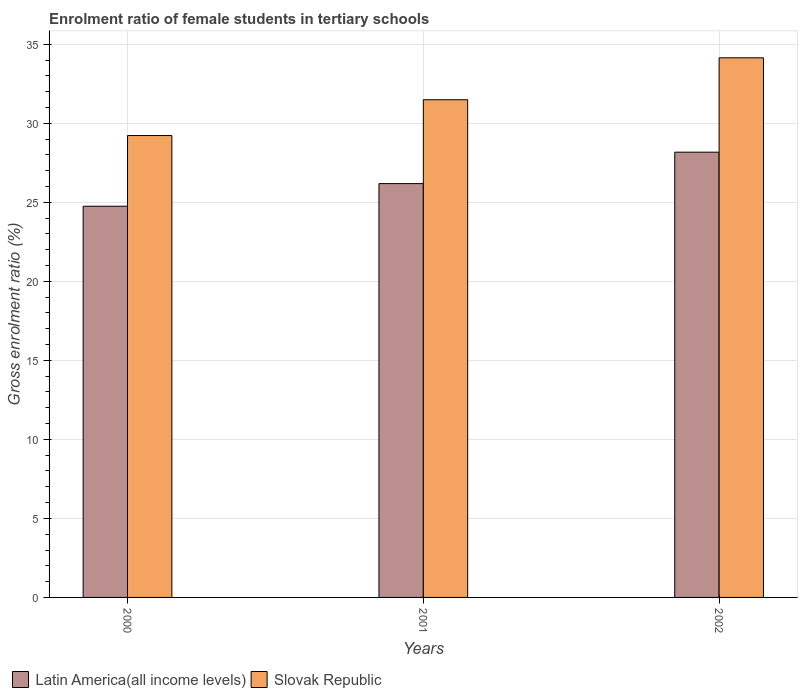Are the number of bars on each tick of the X-axis equal?
Offer a terse response. Yes. How many bars are there on the 2nd tick from the right?
Your response must be concise. 2. What is the enrolment ratio of female students in tertiary schools in Slovak Republic in 2000?
Keep it short and to the point. 29.23. Across all years, what is the maximum enrolment ratio of female students in tertiary schools in Latin America(all income levels)?
Offer a terse response. 28.17. Across all years, what is the minimum enrolment ratio of female students in tertiary schools in Slovak Republic?
Your response must be concise. 29.23. In which year was the enrolment ratio of female students in tertiary schools in Latin America(all income levels) maximum?
Keep it short and to the point. 2002. In which year was the enrolment ratio of female students in tertiary schools in Latin America(all income levels) minimum?
Offer a terse response. 2000. What is the total enrolment ratio of female students in tertiary schools in Latin America(all income levels) in the graph?
Your response must be concise. 79.11. What is the difference between the enrolment ratio of female students in tertiary schools in Slovak Republic in 2001 and that in 2002?
Keep it short and to the point. -2.65. What is the difference between the enrolment ratio of female students in tertiary schools in Latin America(all income levels) in 2000 and the enrolment ratio of female students in tertiary schools in Slovak Republic in 2001?
Keep it short and to the point. -6.74. What is the average enrolment ratio of female students in tertiary schools in Latin America(all income levels) per year?
Your answer should be very brief. 26.37. In the year 2002, what is the difference between the enrolment ratio of female students in tertiary schools in Slovak Republic and enrolment ratio of female students in tertiary schools in Latin America(all income levels)?
Your answer should be very brief. 5.97. What is the ratio of the enrolment ratio of female students in tertiary schools in Latin America(all income levels) in 2000 to that in 2002?
Give a very brief answer. 0.88. Is the enrolment ratio of female students in tertiary schools in Latin America(all income levels) in 2001 less than that in 2002?
Your answer should be very brief. Yes. Is the difference between the enrolment ratio of female students in tertiary schools in Slovak Republic in 2001 and 2002 greater than the difference between the enrolment ratio of female students in tertiary schools in Latin America(all income levels) in 2001 and 2002?
Provide a succinct answer. No. What is the difference between the highest and the second highest enrolment ratio of female students in tertiary schools in Slovak Republic?
Offer a terse response. 2.65. What is the difference between the highest and the lowest enrolment ratio of female students in tertiary schools in Latin America(all income levels)?
Provide a succinct answer. 3.42. Is the sum of the enrolment ratio of female students in tertiary schools in Slovak Republic in 2001 and 2002 greater than the maximum enrolment ratio of female students in tertiary schools in Latin America(all income levels) across all years?
Offer a very short reply. Yes. What does the 1st bar from the left in 2002 represents?
Keep it short and to the point. Latin America(all income levels). What does the 1st bar from the right in 2002 represents?
Make the answer very short. Slovak Republic. How many years are there in the graph?
Your answer should be compact. 3. What is the difference between two consecutive major ticks on the Y-axis?
Your answer should be compact. 5. Does the graph contain any zero values?
Your answer should be compact. No. Where does the legend appear in the graph?
Your answer should be very brief. Bottom left. What is the title of the graph?
Give a very brief answer. Enrolment ratio of female students in tertiary schools. Does "Maldives" appear as one of the legend labels in the graph?
Offer a terse response. No. What is the label or title of the X-axis?
Make the answer very short. Years. What is the Gross enrolment ratio (%) of Latin America(all income levels) in 2000?
Make the answer very short. 24.75. What is the Gross enrolment ratio (%) in Slovak Republic in 2000?
Offer a very short reply. 29.23. What is the Gross enrolment ratio (%) of Latin America(all income levels) in 2001?
Your answer should be very brief. 26.19. What is the Gross enrolment ratio (%) of Slovak Republic in 2001?
Keep it short and to the point. 31.49. What is the Gross enrolment ratio (%) of Latin America(all income levels) in 2002?
Your answer should be compact. 28.17. What is the Gross enrolment ratio (%) of Slovak Republic in 2002?
Your response must be concise. 34.15. Across all years, what is the maximum Gross enrolment ratio (%) of Latin America(all income levels)?
Provide a short and direct response. 28.17. Across all years, what is the maximum Gross enrolment ratio (%) in Slovak Republic?
Give a very brief answer. 34.15. Across all years, what is the minimum Gross enrolment ratio (%) of Latin America(all income levels)?
Offer a very short reply. 24.75. Across all years, what is the minimum Gross enrolment ratio (%) of Slovak Republic?
Your answer should be compact. 29.23. What is the total Gross enrolment ratio (%) of Latin America(all income levels) in the graph?
Keep it short and to the point. 79.11. What is the total Gross enrolment ratio (%) of Slovak Republic in the graph?
Provide a succinct answer. 94.86. What is the difference between the Gross enrolment ratio (%) in Latin America(all income levels) in 2000 and that in 2001?
Provide a short and direct response. -1.43. What is the difference between the Gross enrolment ratio (%) in Slovak Republic in 2000 and that in 2001?
Provide a succinct answer. -2.26. What is the difference between the Gross enrolment ratio (%) of Latin America(all income levels) in 2000 and that in 2002?
Your response must be concise. -3.42. What is the difference between the Gross enrolment ratio (%) in Slovak Republic in 2000 and that in 2002?
Your answer should be compact. -4.92. What is the difference between the Gross enrolment ratio (%) in Latin America(all income levels) in 2001 and that in 2002?
Your answer should be compact. -1.99. What is the difference between the Gross enrolment ratio (%) of Slovak Republic in 2001 and that in 2002?
Provide a short and direct response. -2.65. What is the difference between the Gross enrolment ratio (%) in Latin America(all income levels) in 2000 and the Gross enrolment ratio (%) in Slovak Republic in 2001?
Give a very brief answer. -6.74. What is the difference between the Gross enrolment ratio (%) in Latin America(all income levels) in 2000 and the Gross enrolment ratio (%) in Slovak Republic in 2002?
Provide a succinct answer. -9.39. What is the difference between the Gross enrolment ratio (%) of Latin America(all income levels) in 2001 and the Gross enrolment ratio (%) of Slovak Republic in 2002?
Make the answer very short. -7.96. What is the average Gross enrolment ratio (%) of Latin America(all income levels) per year?
Ensure brevity in your answer.  26.37. What is the average Gross enrolment ratio (%) in Slovak Republic per year?
Offer a very short reply. 31.62. In the year 2000, what is the difference between the Gross enrolment ratio (%) of Latin America(all income levels) and Gross enrolment ratio (%) of Slovak Republic?
Give a very brief answer. -4.47. In the year 2001, what is the difference between the Gross enrolment ratio (%) of Latin America(all income levels) and Gross enrolment ratio (%) of Slovak Republic?
Keep it short and to the point. -5.31. In the year 2002, what is the difference between the Gross enrolment ratio (%) of Latin America(all income levels) and Gross enrolment ratio (%) of Slovak Republic?
Provide a succinct answer. -5.97. What is the ratio of the Gross enrolment ratio (%) of Latin America(all income levels) in 2000 to that in 2001?
Provide a short and direct response. 0.95. What is the ratio of the Gross enrolment ratio (%) in Slovak Republic in 2000 to that in 2001?
Your answer should be very brief. 0.93. What is the ratio of the Gross enrolment ratio (%) of Latin America(all income levels) in 2000 to that in 2002?
Provide a short and direct response. 0.88. What is the ratio of the Gross enrolment ratio (%) in Slovak Republic in 2000 to that in 2002?
Offer a very short reply. 0.86. What is the ratio of the Gross enrolment ratio (%) of Latin America(all income levels) in 2001 to that in 2002?
Ensure brevity in your answer.  0.93. What is the ratio of the Gross enrolment ratio (%) in Slovak Republic in 2001 to that in 2002?
Ensure brevity in your answer.  0.92. What is the difference between the highest and the second highest Gross enrolment ratio (%) in Latin America(all income levels)?
Give a very brief answer. 1.99. What is the difference between the highest and the second highest Gross enrolment ratio (%) in Slovak Republic?
Provide a succinct answer. 2.65. What is the difference between the highest and the lowest Gross enrolment ratio (%) of Latin America(all income levels)?
Offer a very short reply. 3.42. What is the difference between the highest and the lowest Gross enrolment ratio (%) in Slovak Republic?
Provide a short and direct response. 4.92. 